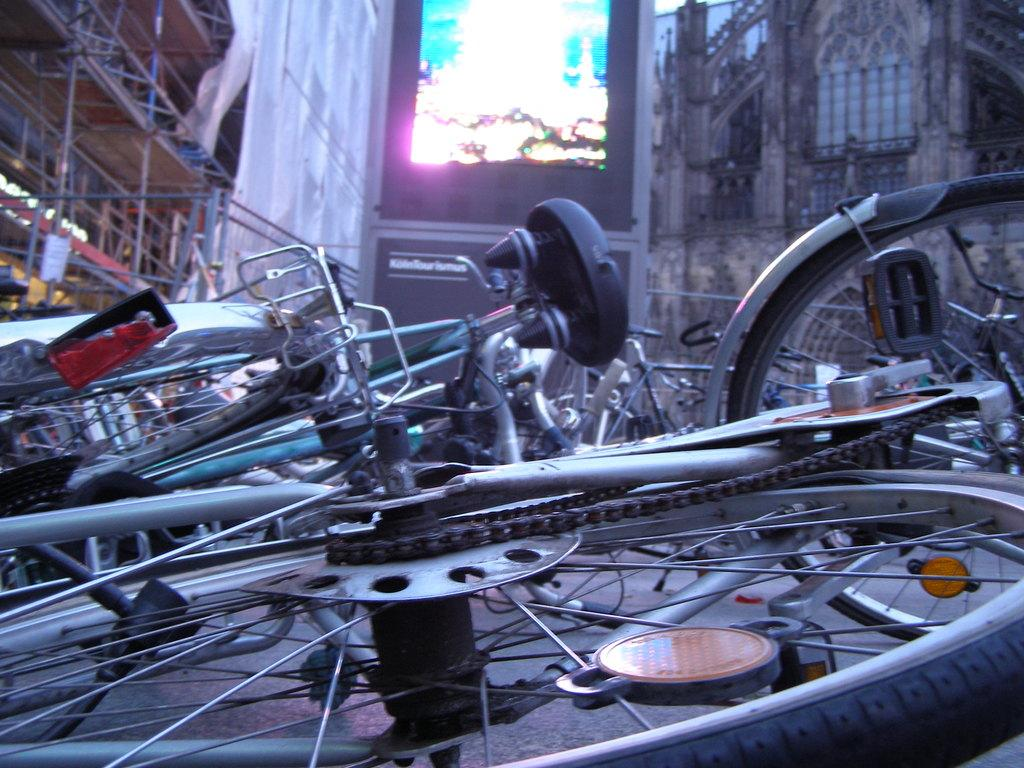What type of vehicles are in the image? There are bicycles in the image. How are the bicycles positioned in the image? Some of the bicycles are on the ground. What else can be seen in the image besides the bicycles? There are buildings visible in the image. What type of lead can be seen being sold in the image? There is no lead or shop present in the image; it features bicycles and buildings. What type of territory is depicted in the image? The image does not depict any specific territory; it simply shows bicycles and buildings. 